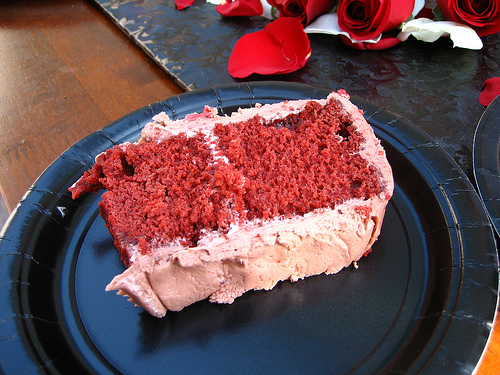<image>
Is there a rose on the plate? No. The rose is not positioned on the plate. They may be near each other, but the rose is not supported by or resting on top of the plate. Is the icing behind the plate? No. The icing is not behind the plate. From this viewpoint, the icing appears to be positioned elsewhere in the scene. 